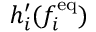Convert formula to latex. <formula><loc_0><loc_0><loc_500><loc_500>h _ { i } ^ { \prime } ( f _ { i } ^ { e q } )</formula> 